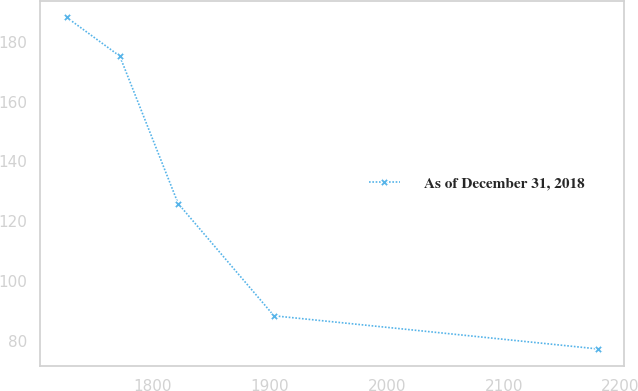Convert chart to OTSL. <chart><loc_0><loc_0><loc_500><loc_500><line_chart><ecel><fcel>As of December 31, 2018<nl><fcel>1726.12<fcel>188.11<nl><fcel>1771.57<fcel>175.18<nl><fcel>1821.52<fcel>125.93<nl><fcel>1903.49<fcel>88.46<nl><fcel>2180.62<fcel>77.39<nl></chart> 